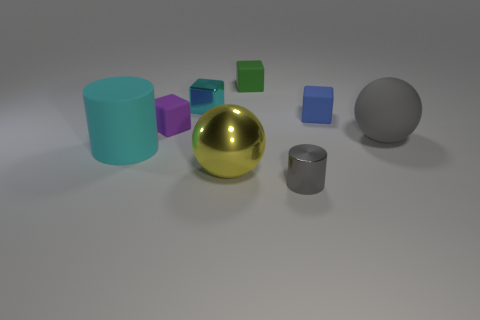Do the gray cylinder and the cyan thing that is on the left side of the purple matte cube have the same material?
Keep it short and to the point. No. What number of spheres are both in front of the large cyan cylinder and right of the shiny cylinder?
Your answer should be compact. 0. There is a cyan object that is the same size as the yellow metal thing; what shape is it?
Make the answer very short. Cylinder. There is a cube that is to the right of the tiny thing in front of the big matte cylinder; is there a large cylinder behind it?
Ensure brevity in your answer.  No. There is a big matte cylinder; is it the same color as the ball that is to the left of the big gray thing?
Offer a terse response. No. What number of other balls are the same color as the matte ball?
Your answer should be very brief. 0. What is the size of the metal thing that is behind the gray matte ball in front of the purple object?
Your answer should be very brief. Small. How many objects are either tiny blocks to the left of the metallic sphere or small red shiny cylinders?
Your answer should be compact. 2. Is there a yellow metallic object of the same size as the cyan rubber object?
Make the answer very short. Yes. There is a large ball right of the blue rubber thing; are there any gray things that are in front of it?
Your response must be concise. Yes. 